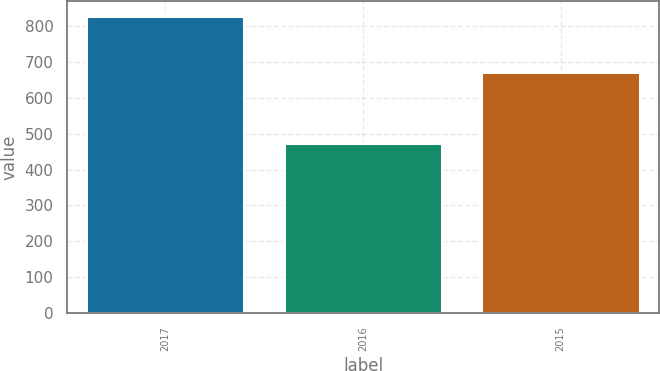Convert chart. <chart><loc_0><loc_0><loc_500><loc_500><bar_chart><fcel>2017<fcel>2016<fcel>2015<nl><fcel>828<fcel>474<fcel>672<nl></chart> 